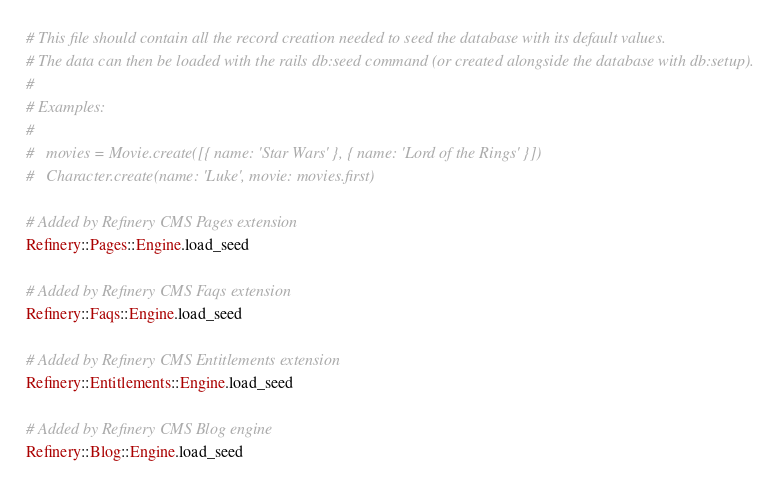Convert code to text. <code><loc_0><loc_0><loc_500><loc_500><_Ruby_># This file should contain all the record creation needed to seed the database with its default values.
# The data can then be loaded with the rails db:seed command (or created alongside the database with db:setup).
#
# Examples:
#
#   movies = Movie.create([{ name: 'Star Wars' }, { name: 'Lord of the Rings' }])
#   Character.create(name: 'Luke', movie: movies.first)

# Added by Refinery CMS Pages extension
Refinery::Pages::Engine.load_seed

# Added by Refinery CMS Faqs extension
Refinery::Faqs::Engine.load_seed

# Added by Refinery CMS Entitlements extension
Refinery::Entitlements::Engine.load_seed

# Added by Refinery CMS Blog engine
Refinery::Blog::Engine.load_seed
</code> 